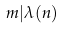<formula> <loc_0><loc_0><loc_500><loc_500>m | \lambda ( n )</formula> 